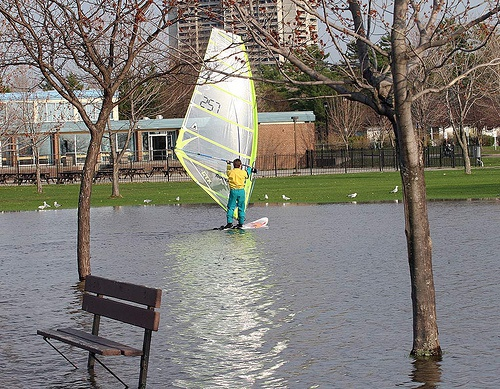Describe the objects in this image and their specific colors. I can see bench in lavender, black, and gray tones, people in lavender, teal, khaki, and black tones, surfboard in lavender, lightgray, darkgray, lightpink, and gray tones, bird in lavender, darkgreen, white, olive, and darkgray tones, and bird in lavender, darkgreen, darkgray, gray, and olive tones in this image. 